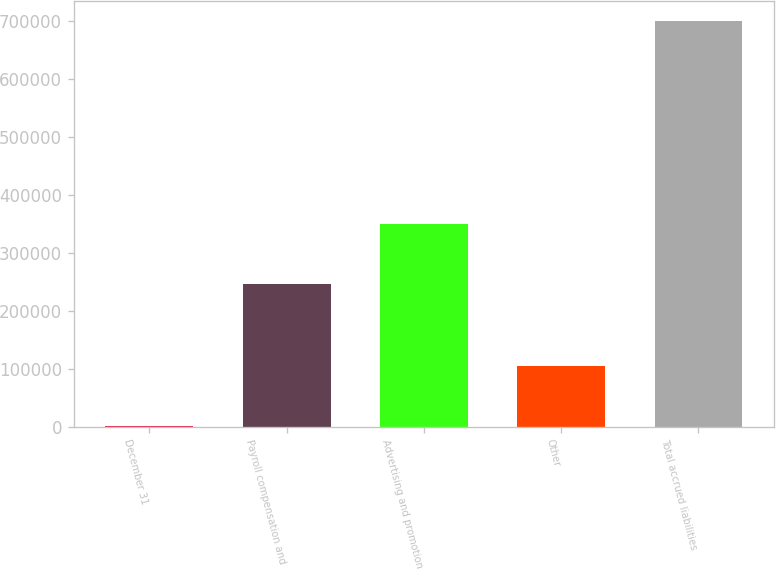<chart> <loc_0><loc_0><loc_500><loc_500><bar_chart><fcel>December 31<fcel>Payroll compensation and<fcel>Advertising and promotion<fcel>Other<fcel>Total accrued liabilities<nl><fcel>2013<fcel>245641<fcel>348966<fcel>105115<fcel>699722<nl></chart> 